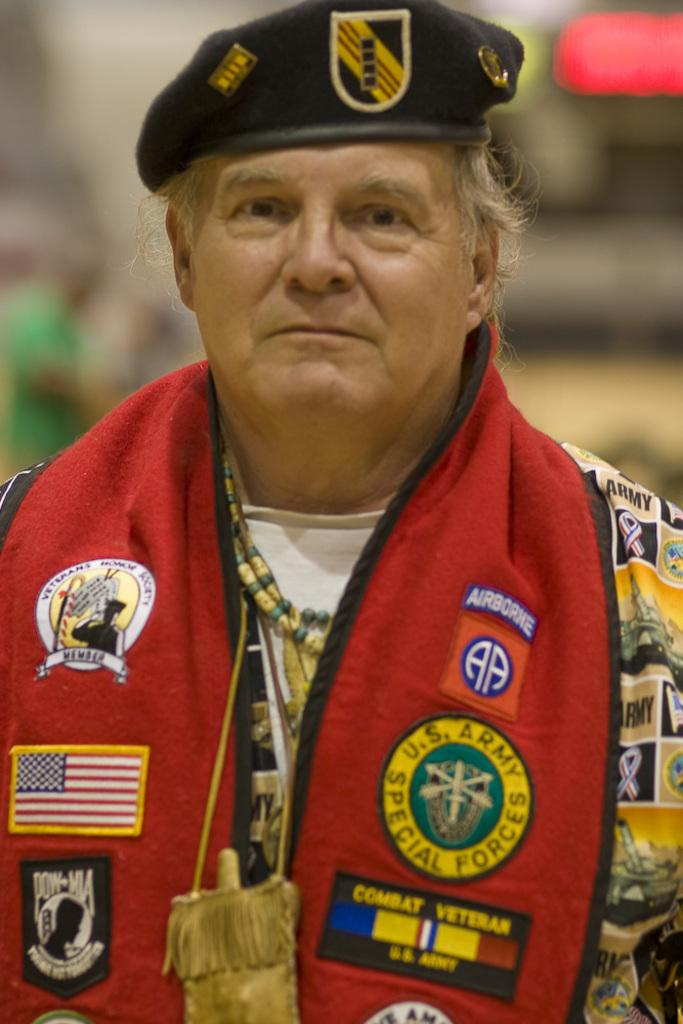What is the main subject of the image? There is a person in the image. What is the person doing in the image? The person is standing and smiling. Can you describe the background of the image? The background of the image is blurred. What type of yam is the person holding in the image? There is no yam present in the image; the person is not holding anything. Can you tell me how many times the person has combed their hair in the image? There is no indication of the person's hair or any combing activity in the image. 